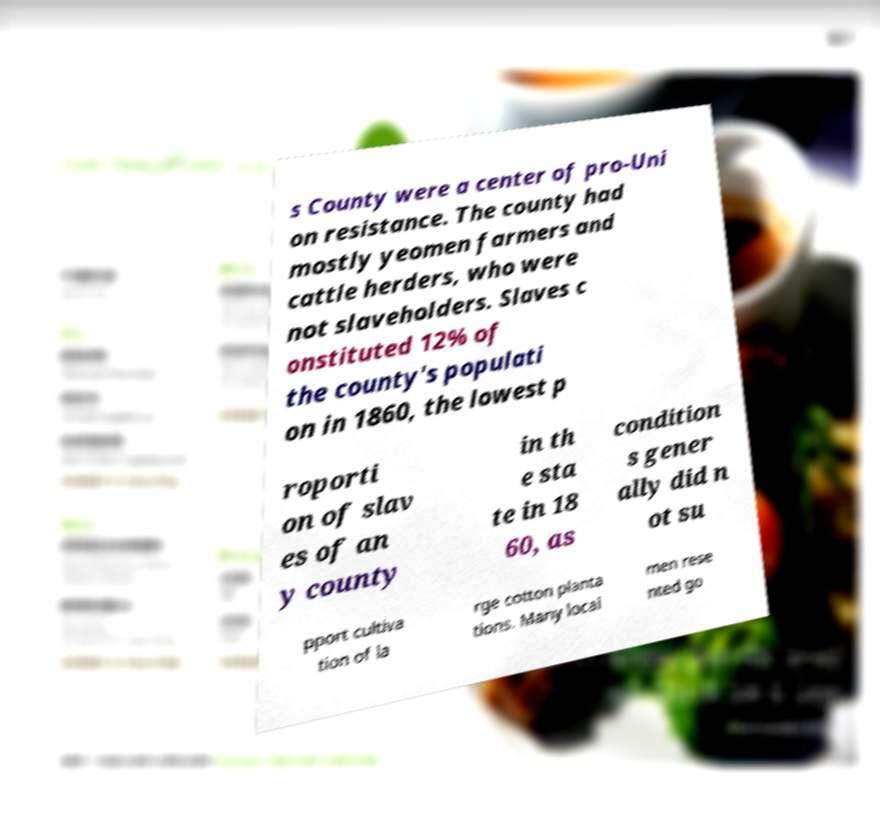Can you accurately transcribe the text from the provided image for me? s County were a center of pro-Uni on resistance. The county had mostly yeomen farmers and cattle herders, who were not slaveholders. Slaves c onstituted 12% of the county's populati on in 1860, the lowest p roporti on of slav es of an y county in th e sta te in 18 60, as condition s gener ally did n ot su pport cultiva tion of la rge cotton planta tions. Many local men rese nted go 